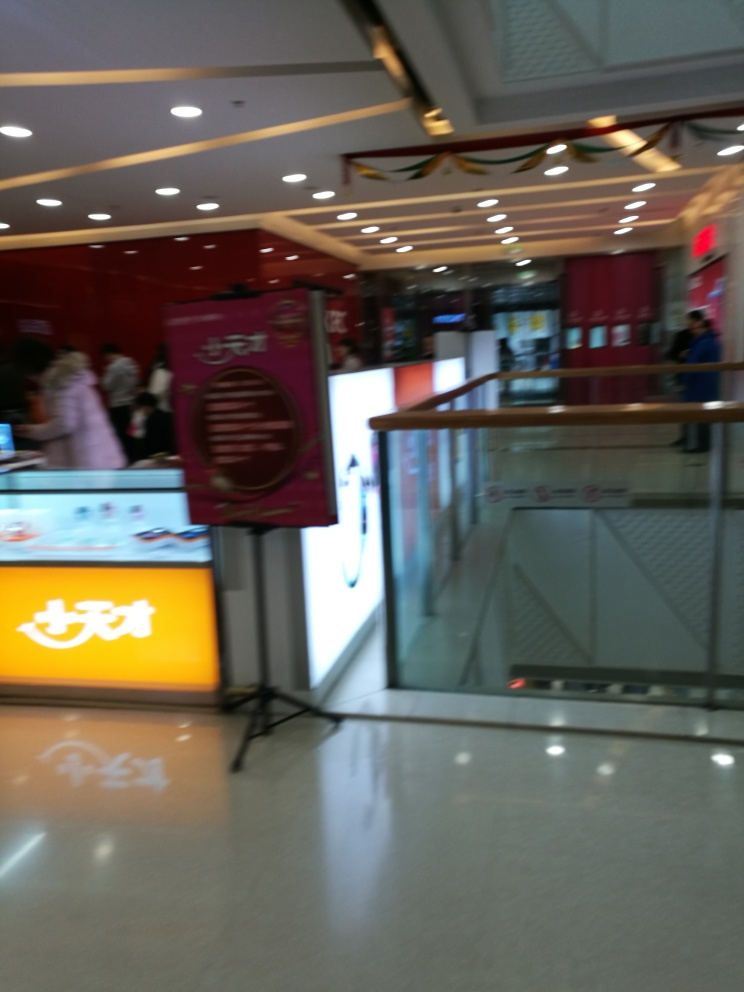Describe the atmosphere or mood this image conveys. Although the blurriness limits the details, the bright lighting and colorful signage suggest a bustling, lively atmosphere typically associated with commercial shopping areas. The image evokes a sense of everyday activity and commerce. 